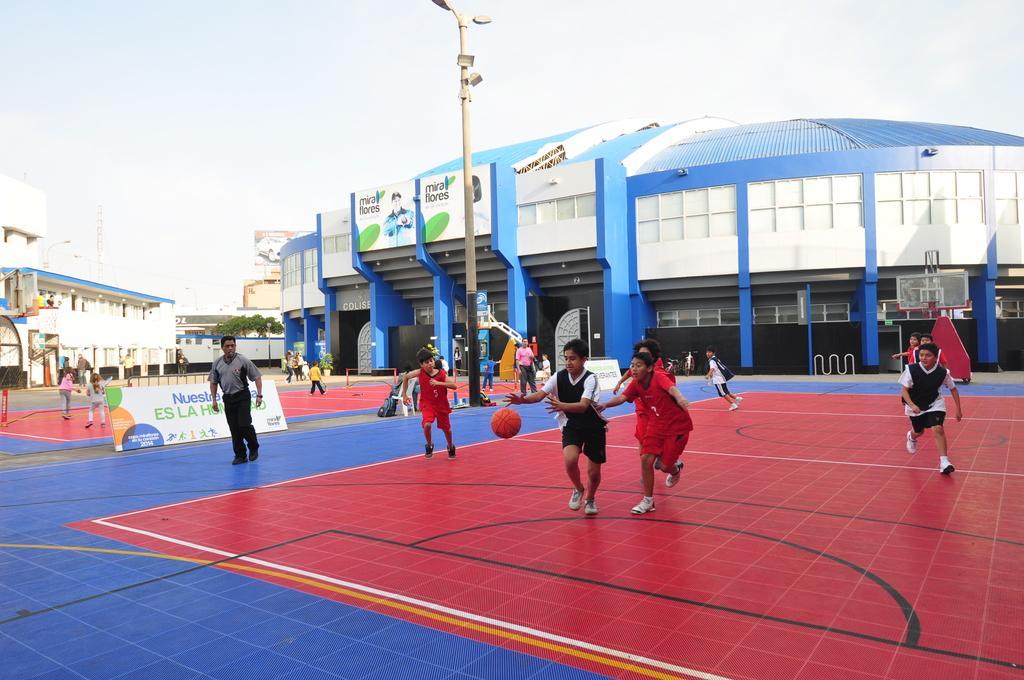How would you summarize this image in a sentence or two? In this image we can see a few people, some of them are playing basketball, there is a light pole at the center of the image, there are some boards with text written on them, there are buildings, basketball stands, tower, and a ball, also we can see the sky. 